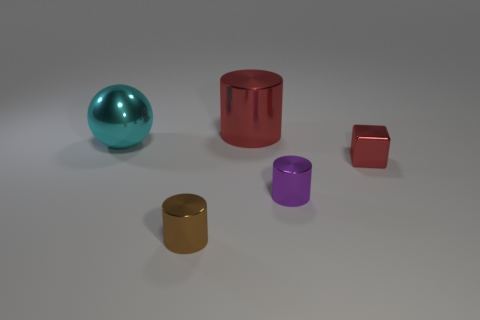Add 4 large blue matte objects. How many objects exist? 9 Subtract all cubes. How many objects are left? 4 Add 3 large metal cylinders. How many large metal cylinders are left? 4 Add 4 red blocks. How many red blocks exist? 5 Subtract 0 gray blocks. How many objects are left? 5 Subtract all large cyan shiny objects. Subtract all purple metallic objects. How many objects are left? 3 